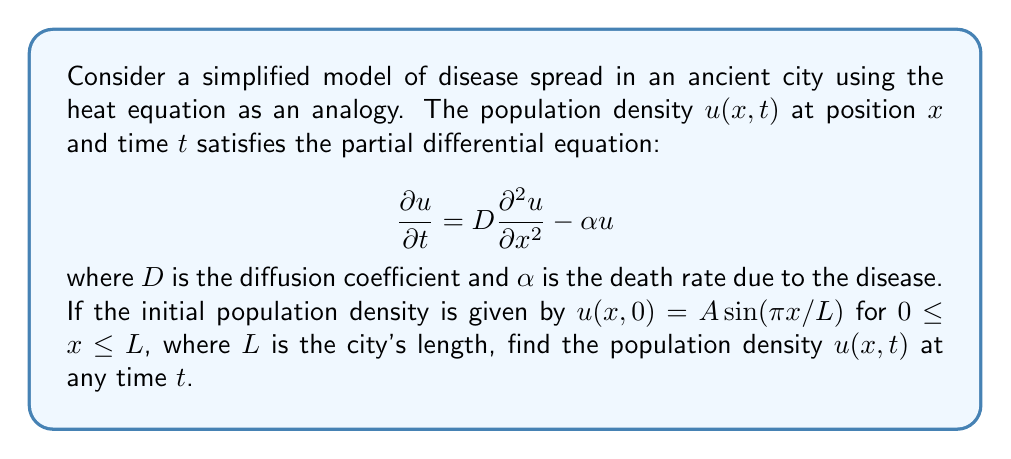Solve this math problem. To solve this partial differential equation (PDE), we'll use the method of separation of variables:

1) Assume a solution of the form $u(x,t) = X(x)T(t)$.

2) Substituting this into the PDE:

   $$X(x)\frac{dT}{dt} = DT(t)\frac{d^2X}{dx^2} - \alpha X(x)T(t)$$

3) Dividing both sides by $X(x)T(t)$:

   $$\frac{1}{T}\frac{dT}{dt} = D\frac{1}{X}\frac{d^2X}{dx^2} - \alpha$$

4) The left side depends only on $t$, and the right side depends only on $x$. For this to be true for all $x$ and $t$, both sides must equal a constant, say $-\lambda$:

   $$\frac{1}{T}\frac{dT}{dt} = -\lambda$$
   $$D\frac{1}{X}\frac{d^2X}{dx^2} - \alpha = -\lambda$$

5) From the $T$ equation: $T(t) = Ce^{-\lambda t}$

6) The $X$ equation can be rewritten as:

   $$\frac{d^2X}{dx^2} + \frac{\lambda - \alpha}{D}X = 0$$

7) This has solutions of the form $X(x) = A\sin(kx) + B\cos(kx)$, where $k^2 = \frac{\lambda - \alpha}{D}$

8) Given the boundary conditions (implied by the initial condition), we need $X(0) = X(L) = 0$. This gives $B = 0$ and $k = n\pi/L$ for integer $n$.

9) Therefore, $\lambda_n = D(n\pi/L)^2 + \alpha$

10) The general solution is a sum of all possible solutions:

    $$u(x,t) = \sum_{n=1}^{\infty} A_n \sin(\frac{n\pi x}{L})e^{-(D(n\pi/L)^2 + \alpha)t}$$

11) To match the initial condition, we need:

    $$u(x,0) = A\sin(\pi x/L) = \sum_{n=1}^{\infty} A_n \sin(\frac{n\pi x}{L})$$

12) This means $A_1 = A$ and $A_n = 0$ for $n > 1$.

Therefore, the final solution is:

$$u(x,t) = A\sin(\frac{\pi x}{L})e^{-(D(\pi/L)^2 + \alpha)t}$$
Answer: $u(x,t) = A\sin(\frac{\pi x}{L})e^{-(D(\pi/L)^2 + \alpha)t}$ 